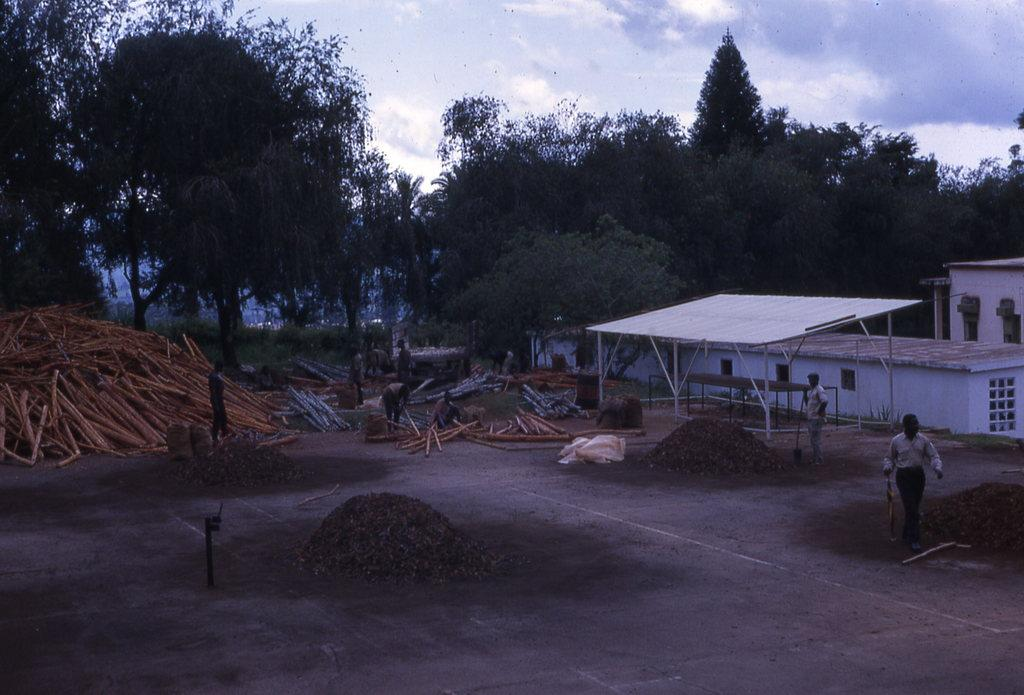What can be seen in the image that has been dumped? There are materials dumped in the image. What are the people in the image doing? People are working in the image. What can be seen in the background of the image? There are wooden poles, sheds, trees, and the sky visible in the background of the image. What type of garden can be seen in the image? There is no garden present in the image. What is the purpose of the peace symbol in the image? There is no peace symbol present in the image. 